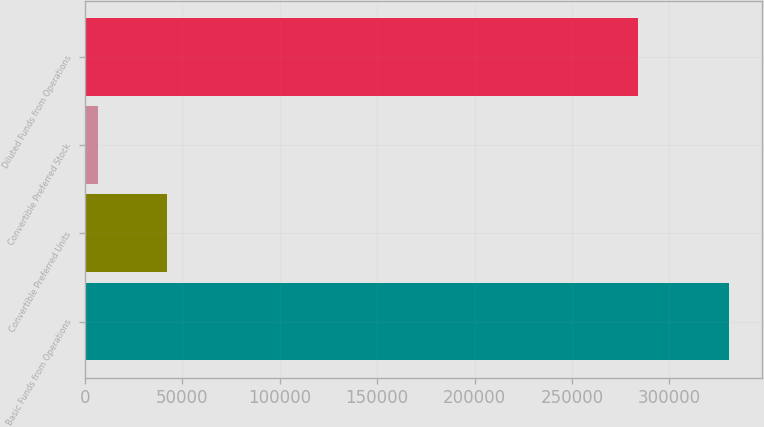Convert chart. <chart><loc_0><loc_0><loc_500><loc_500><bar_chart><fcel>Basic Funds from Operations<fcel>Convertible Preferred Units<fcel>Convertible Preferred Stock<fcel>Diluted Funds from Operations<nl><fcel>330868<fcel>42301<fcel>6572<fcel>283994<nl></chart> 